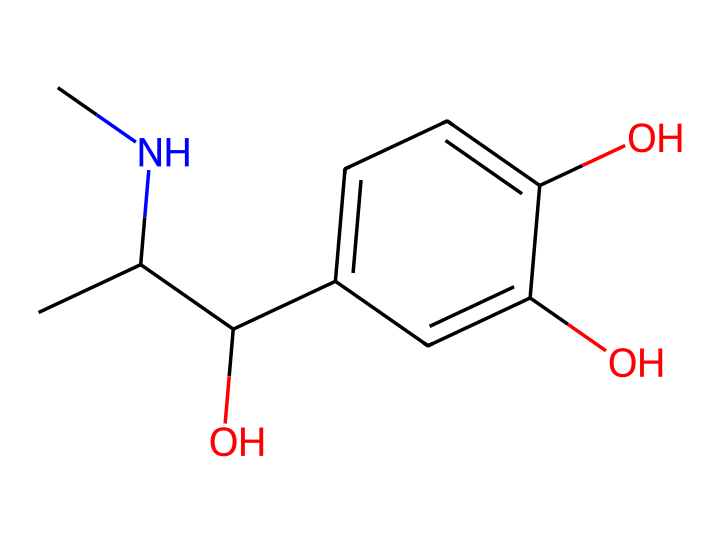What is the chemical name for this compound? The SMILES representation corresponds to adrenaline, which is also known as epinephrine. This can be deduced from the structure and common naming conventions in organic chemistry for this specific hormone.
Answer: adrenaline How many hydroxyl groups are present in this structure? The chemical structure reveals three hydroxyl (-OH) groups based on the indicated -OH attachments on the aromatic ring and the aliphatic carbon. Therefore, counting these groups provides the answer.
Answer: 3 What is the total number of carbon atoms in this molecule? By analyzing the SMILES representation, we can count the carbon atoms in both the aliphatic and aromatic portions of the molecule. There are ten carbon atoms in total.
Answer: 10 Which functional groups can be identified in this chemical structure? This structure contains hydroxyl groups, evidenced by the presence of -OH, along with an amine group (-NH2) at a carbon chain. Recognizing these groups allows us to identify the functional characteristics specific to adrenaline.
Answer: hydroxyl and amine What type of hormone is adrenaline classified as? Adrenaline is classified as a catecholamine, which is a specific class of hormones derived from amino acids and characterized by their structure and function. This classification is linked to its biochemical properties and effects on the body.
Answer: catecholamine What is the stereochemistry of the carbon that is attached to the amine group? The presence of the stereocenter at the carbon attached to the amine group can be inferred from its connectivity, showing chirality. This leads to identifying that this carbon has a specific S configuration given the spatial arrangement of the surrounding groups.
Answer: S configuration 